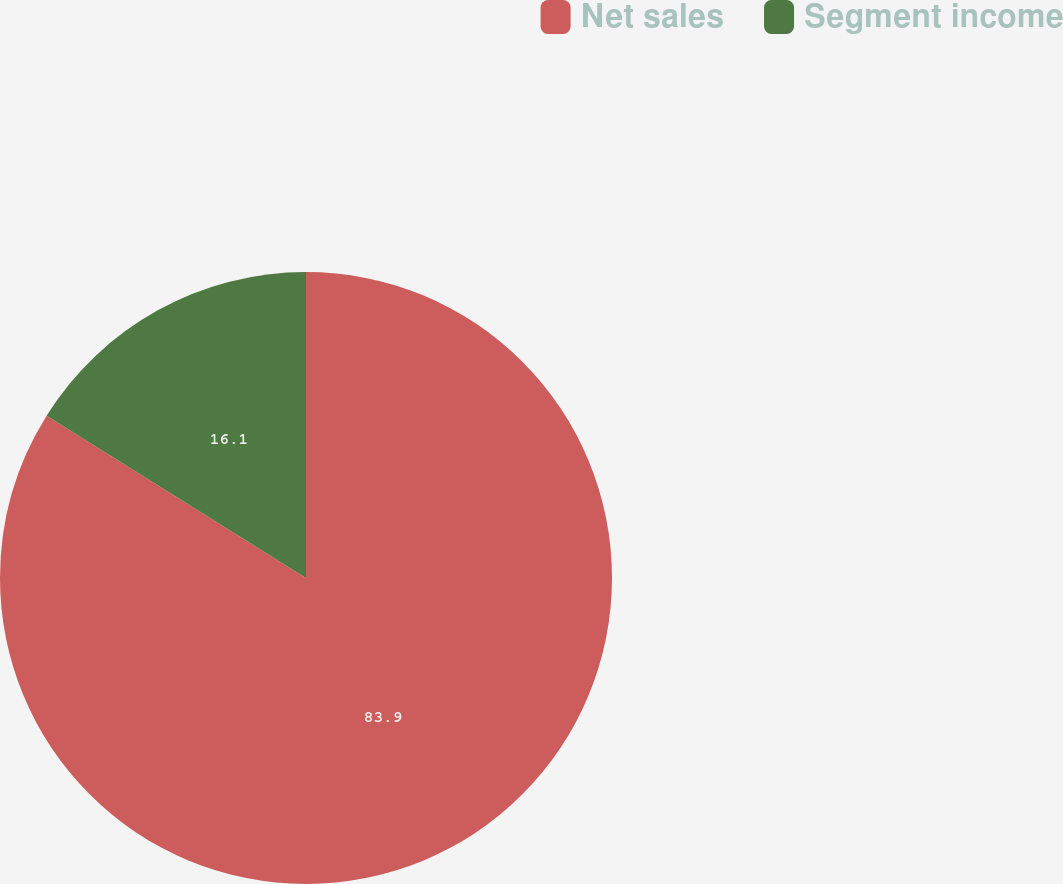Convert chart to OTSL. <chart><loc_0><loc_0><loc_500><loc_500><pie_chart><fcel>Net sales<fcel>Segment income<nl><fcel>83.9%<fcel>16.1%<nl></chart> 